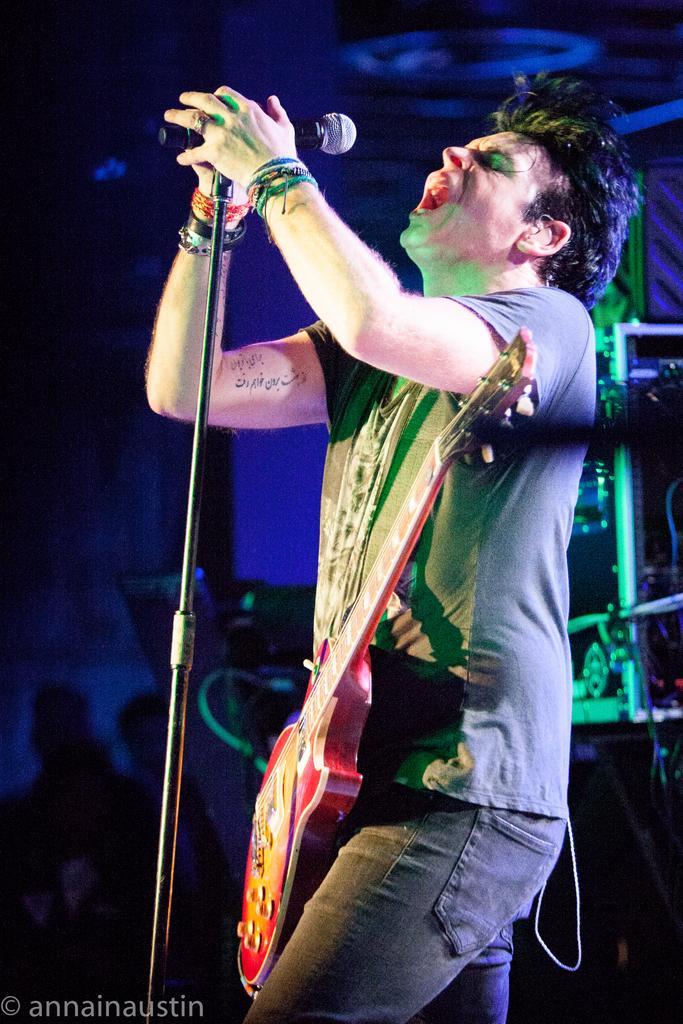How would you summarize this image in a sentence or two? Here in this picture we can see a man holding a mic and singing. The mic is connected to the stand. He is wearing guitar band around his neck. To his both the hands there are some bands, hand bands. He is wearing a t-shirt and a jeans. Behind him there are some boxes. 